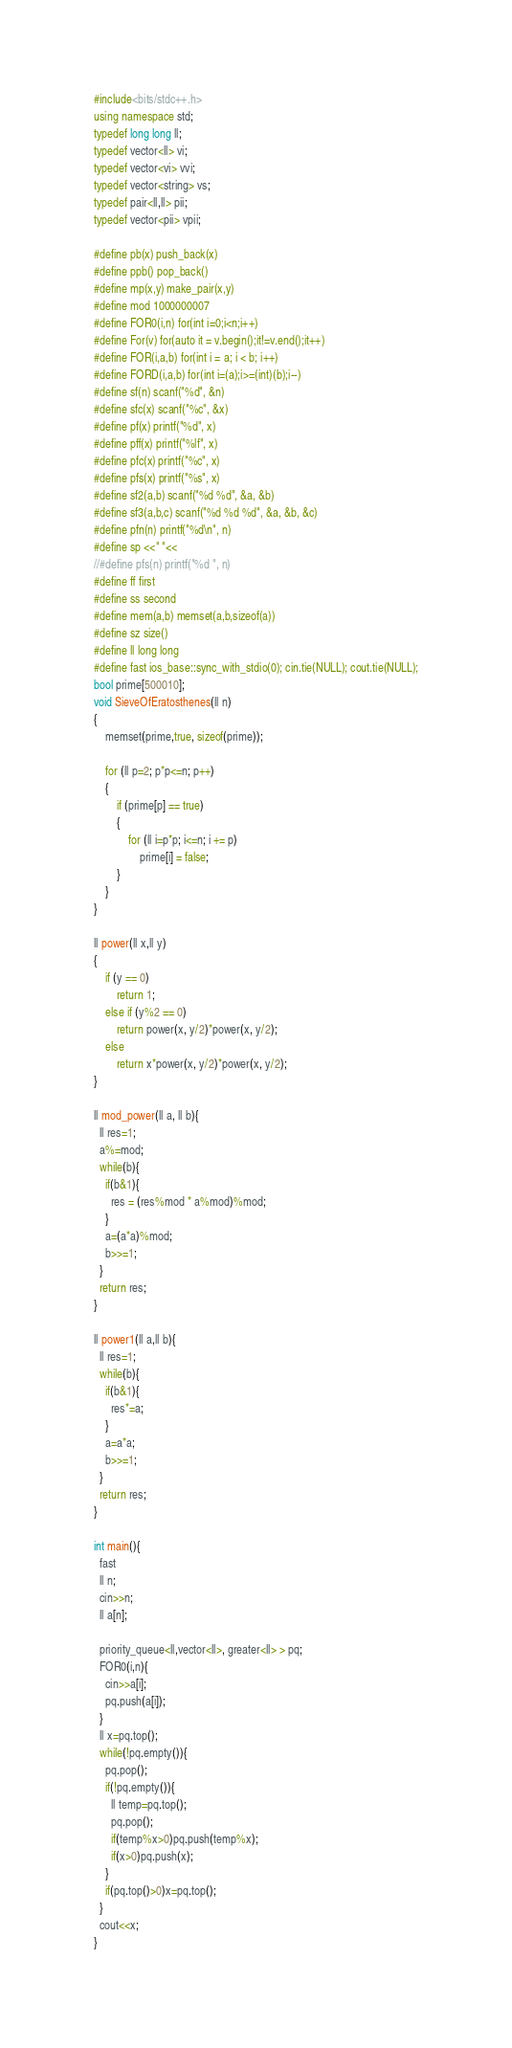<code> <loc_0><loc_0><loc_500><loc_500><_C++_>#include<bits/stdc++.h>
using namespace std;
typedef long long ll;
typedef vector<ll> vi;
typedef vector<vi> vvi;
typedef vector<string> vs;
typedef pair<ll,ll> pii;
typedef vector<pii> vpii;
 
#define pb(x) push_back(x)
#define ppb() pop_back()
#define mp(x,y) make_pair(x,y)
#define mod 1000000007
#define FOR0(i,n) for(int i=0;i<n;i++)
#define For(v) for(auto it = v.begin();it!=v.end();it++)
#define FOR(i,a,b) for(int i = a; i < b; i++)
#define FORD(i,a,b) for(int i=(a);i>=(int)(b);i--)
#define sf(n) scanf("%d", &n)
#define sfc(x) scanf("%c", &x)
#define pf(x) printf("%d", x)
#define pff(x) printf("%lf", x)
#define pfc(x) printf("%c", x)
#define pfs(x) printf("%s", x)
#define sf2(a,b) scanf("%d %d", &a, &b)
#define sf3(a,b,c) scanf("%d %d %d", &a, &b, &c)
#define pfn(n) printf("%d\n", n)
#define sp <<" "<<
//#define pfs(n) printf("%d ", n)
#define ff first
#define ss second
#define mem(a,b) memset(a,b,sizeof(a))
#define sz size()
#define ll long long
#define fast ios_base::sync_with_stdio(0); cin.tie(NULL); cout.tie(NULL);
bool prime[500010];
void SieveOfEratosthenes(ll n)
{
    memset(prime,true, sizeof(prime));
 
    for (ll p=2; p*p<=n; p++)
    {
        if (prime[p] == true)
        {
            for (ll i=p*p; i<=n; i += p)
                prime[i] = false;
        }
    }
}
 
ll power(ll x,ll y)
{
    if (y == 0)
        return 1;
    else if (y%2 == 0)
        return power(x, y/2)*power(x, y/2);
    else
        return x*power(x, y/2)*power(x, y/2);
}
 
ll mod_power(ll a, ll b){
  ll res=1;
  a%=mod;
  while(b){
    if(b&1){
      res = (res%mod * a%mod)%mod;
    }
    a=(a*a)%mod;
    b>>=1;
  }
  return res;
} 

ll power1(ll a,ll b){
  ll res=1;
  while(b){
    if(b&1){
      res*=a;
    }
    a=a*a;
    b>>=1;
  }
  return res;
}

int main(){
  fast
  ll n;
  cin>>n;
  ll a[n];
  
  priority_queue<ll,vector<ll>, greater<ll> > pq;
  FOR0(i,n){
    cin>>a[i];
    pq.push(a[i]);
  }
  ll x=pq.top();
  while(!pq.empty()){
    pq.pop();
    if(!pq.empty()){
      ll temp=pq.top();
      pq.pop();
      if(temp%x>0)pq.push(temp%x);
      if(x>0)pq.push(x);
    }
    if(pq.top()>0)x=pq.top();
  }
  cout<<x;
}</code> 